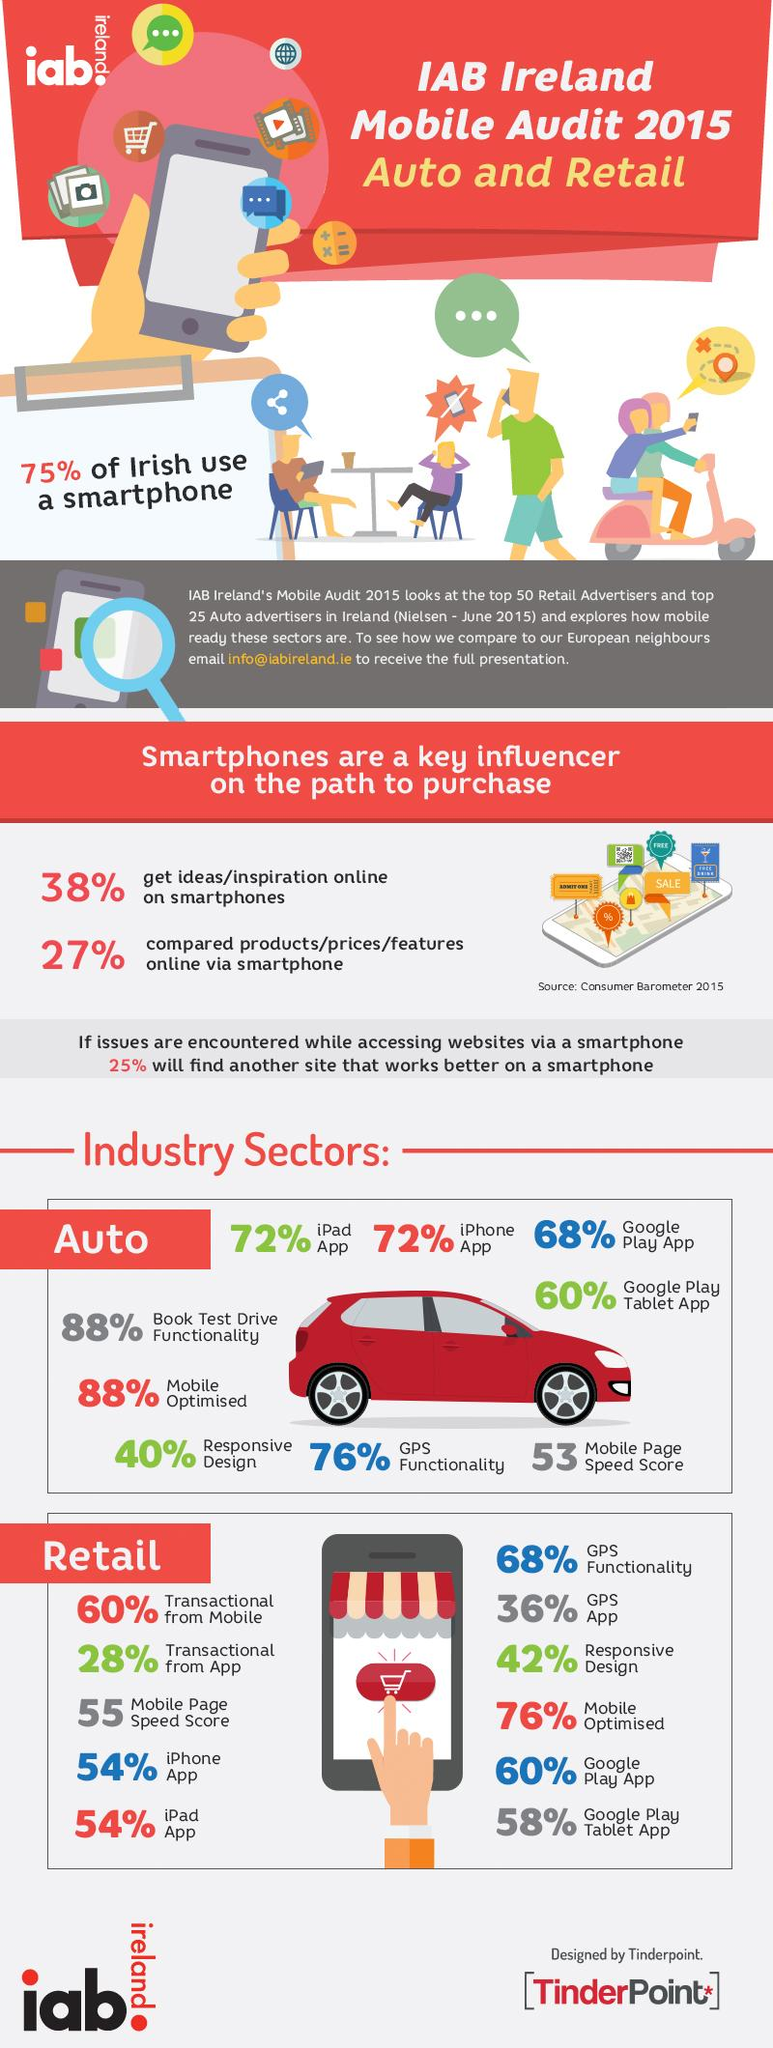List a handful of essential elements in this visual. According to a survey, 88% of websites are optimized for mobile devices in the automotive sector. According to a study, 76% of websites in the retail sector are mobile optimized. The mobile page speed score for the industrial sector related to automobiles is 53. In the retail sector, a significant percentage of websites support Google Play Tablet App. Specifically, 58% of websites support this app. In the retail sector, it is estimated that approximately 36% of websites support the use of GPS apps. 